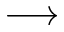<formula> <loc_0><loc_0><loc_500><loc_500>\longrightarrow</formula> 